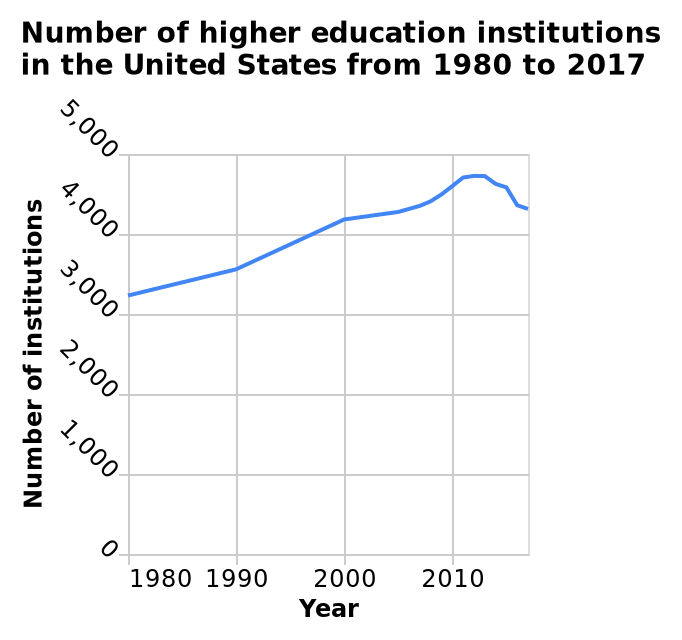<image>
How many institutions increased during this period? Nine hundred institutions increased during this period. How many higher education institutions were there in the United States in 2017?  The line diagram does not provide information about the exact number of higher education institutions in the United States in 2017. 